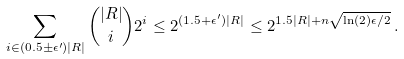Convert formula to latex. <formula><loc_0><loc_0><loc_500><loc_500>\sum _ { i \in ( 0 . 5 \pm \epsilon ^ { \prime } ) | R | } \binom { | R | } { i } 2 ^ { i } \leq 2 ^ { ( 1 . 5 + \epsilon ^ { \prime } ) | R | } \leq 2 ^ { 1 . 5 | R | + n \sqrt { \ln ( 2 ) \epsilon / 2 } } \, .</formula> 